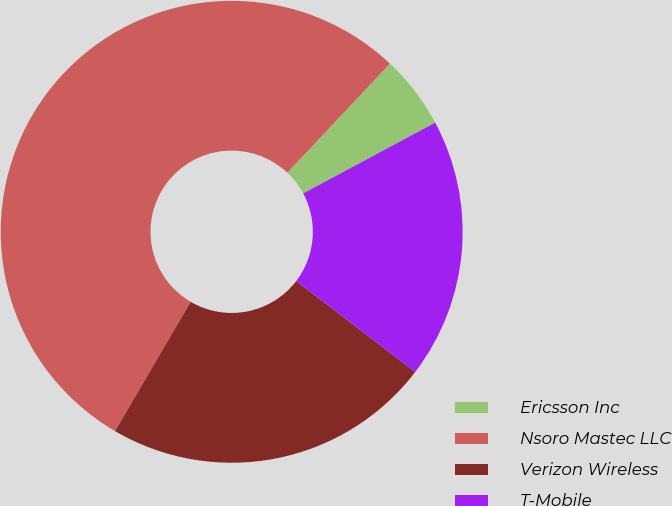Convert chart. <chart><loc_0><loc_0><loc_500><loc_500><pie_chart><fcel>Ericsson Inc<fcel>Nsoro Mastec LLC<fcel>Verizon Wireless<fcel>T-Mobile<nl><fcel>5.15%<fcel>53.59%<fcel>23.05%<fcel>18.21%<nl></chart> 